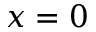<formula> <loc_0><loc_0><loc_500><loc_500>x = 0</formula> 